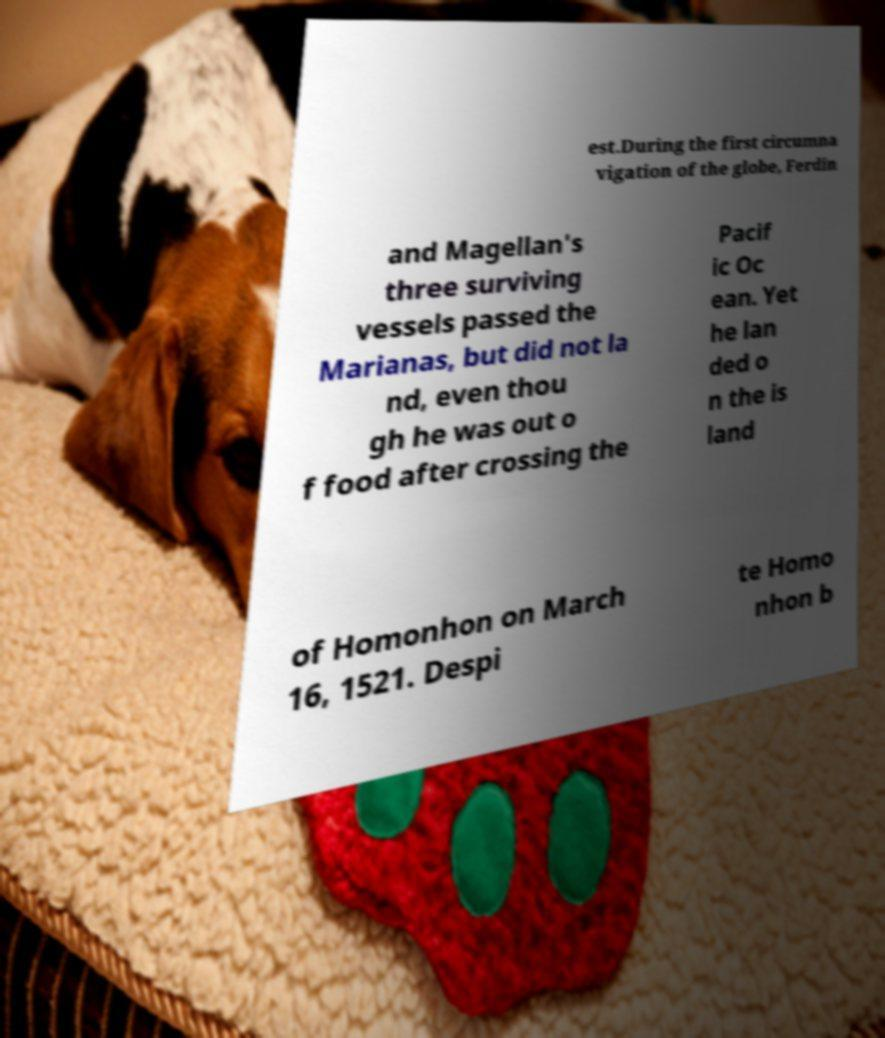For documentation purposes, I need the text within this image transcribed. Could you provide that? est.During the first circumna vigation of the globe, Ferdin and Magellan's three surviving vessels passed the Marianas, but did not la nd, even thou gh he was out o f food after crossing the Pacif ic Oc ean. Yet he lan ded o n the is land of Homonhon on March 16, 1521. Despi te Homo nhon b 